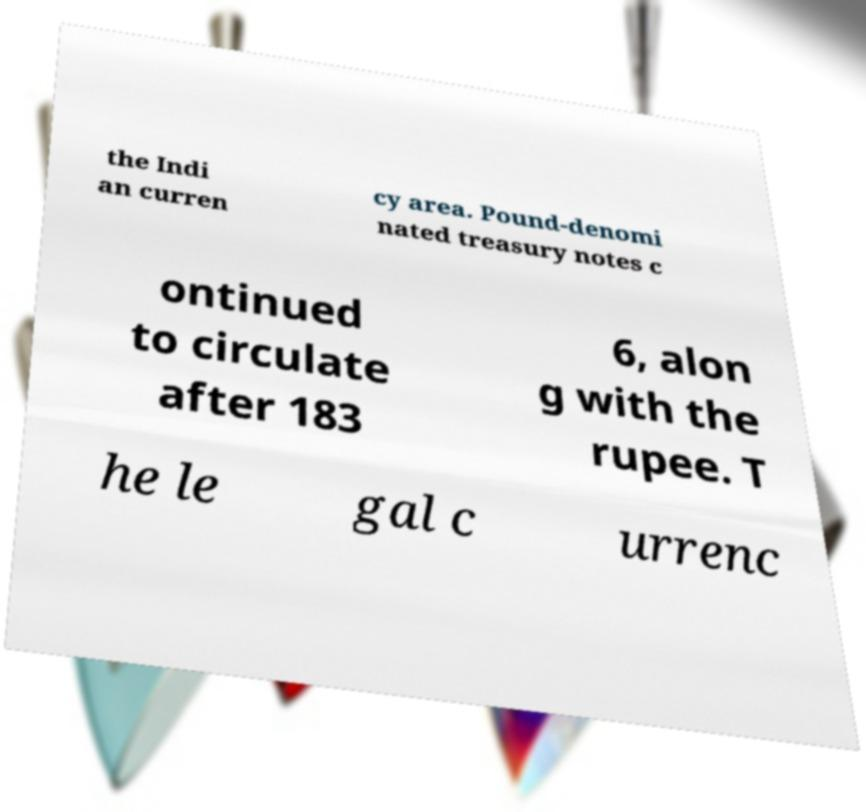For documentation purposes, I need the text within this image transcribed. Could you provide that? the Indi an curren cy area. Pound-denomi nated treasury notes c ontinued to circulate after 183 6, alon g with the rupee. T he le gal c urrenc 